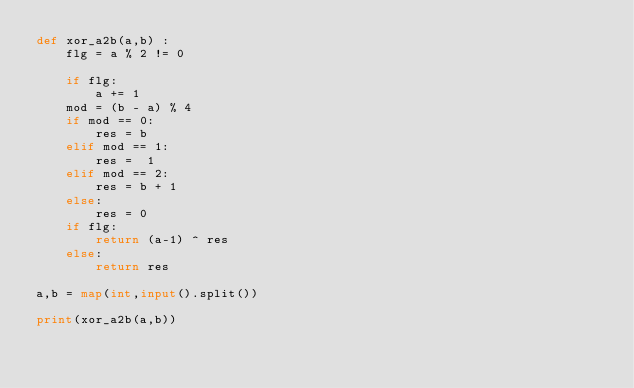<code> <loc_0><loc_0><loc_500><loc_500><_Python_>def xor_a2b(a,b) : 
    flg = a % 2 != 0
    
    if flg: 
        a += 1
    mod = (b - a) % 4
    if mod == 0:
        res = b
    elif mod == 1:
        res =  1
    elif mod == 2:
        res = b + 1
    else:
        res = 0
    if flg:
        return (a-1) ^ res
    else:
        return res
      
a,b = map(int,input().split())

print(xor_a2b(a,b))</code> 